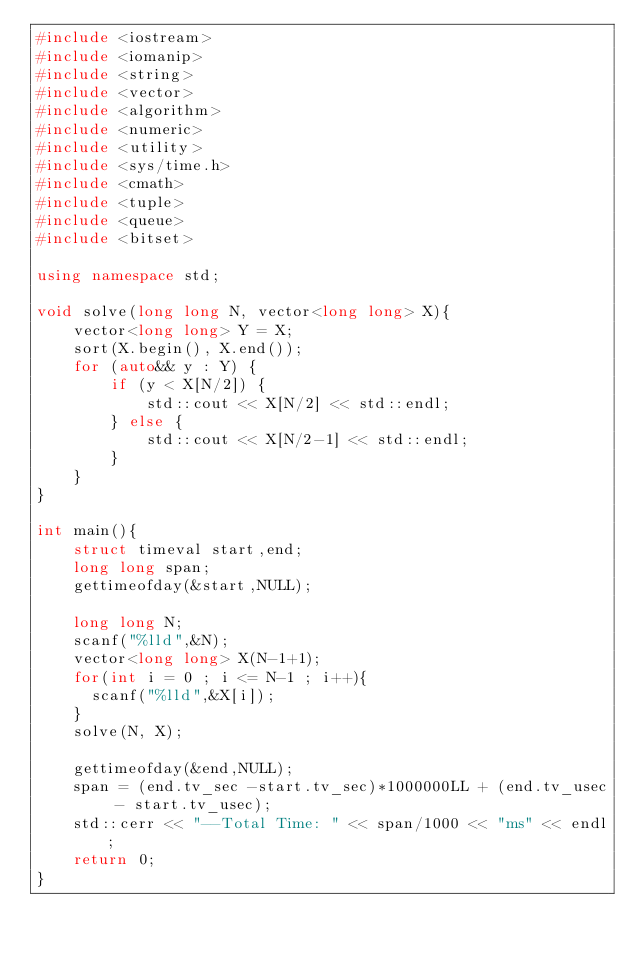Convert code to text. <code><loc_0><loc_0><loc_500><loc_500><_C++_>#include <iostream>
#include <iomanip>
#include <string>
#include <vector>
#include <algorithm>
#include <numeric>
#include <utility>
#include <sys/time.h>
#include <cmath>
#include <tuple>
#include <queue>
#include <bitset>

using namespace std;

void solve(long long N, vector<long long> X){
    vector<long long> Y = X;
    sort(X.begin(), X.end());
    for (auto&& y : Y) {
        if (y < X[N/2]) {
            std::cout << X[N/2] << std::endl;
        } else {
            std::cout << X[N/2-1] << std::endl;
        }
    }
}

int main(){	
    struct timeval start,end;
    long long span;
    gettimeofday(&start,NULL);

    long long N;
    scanf("%lld",&N);
    vector<long long> X(N-1+1);
    for(int i = 0 ; i <= N-1 ; i++){
    	scanf("%lld",&X[i]);
    }
    solve(N, X);

    gettimeofday(&end,NULL);
    span = (end.tv_sec -start.tv_sec)*1000000LL + (end.tv_usec - start.tv_usec);
    std::cerr << "--Total Time: " << span/1000 << "ms" << endl;
    return 0;
}
</code> 